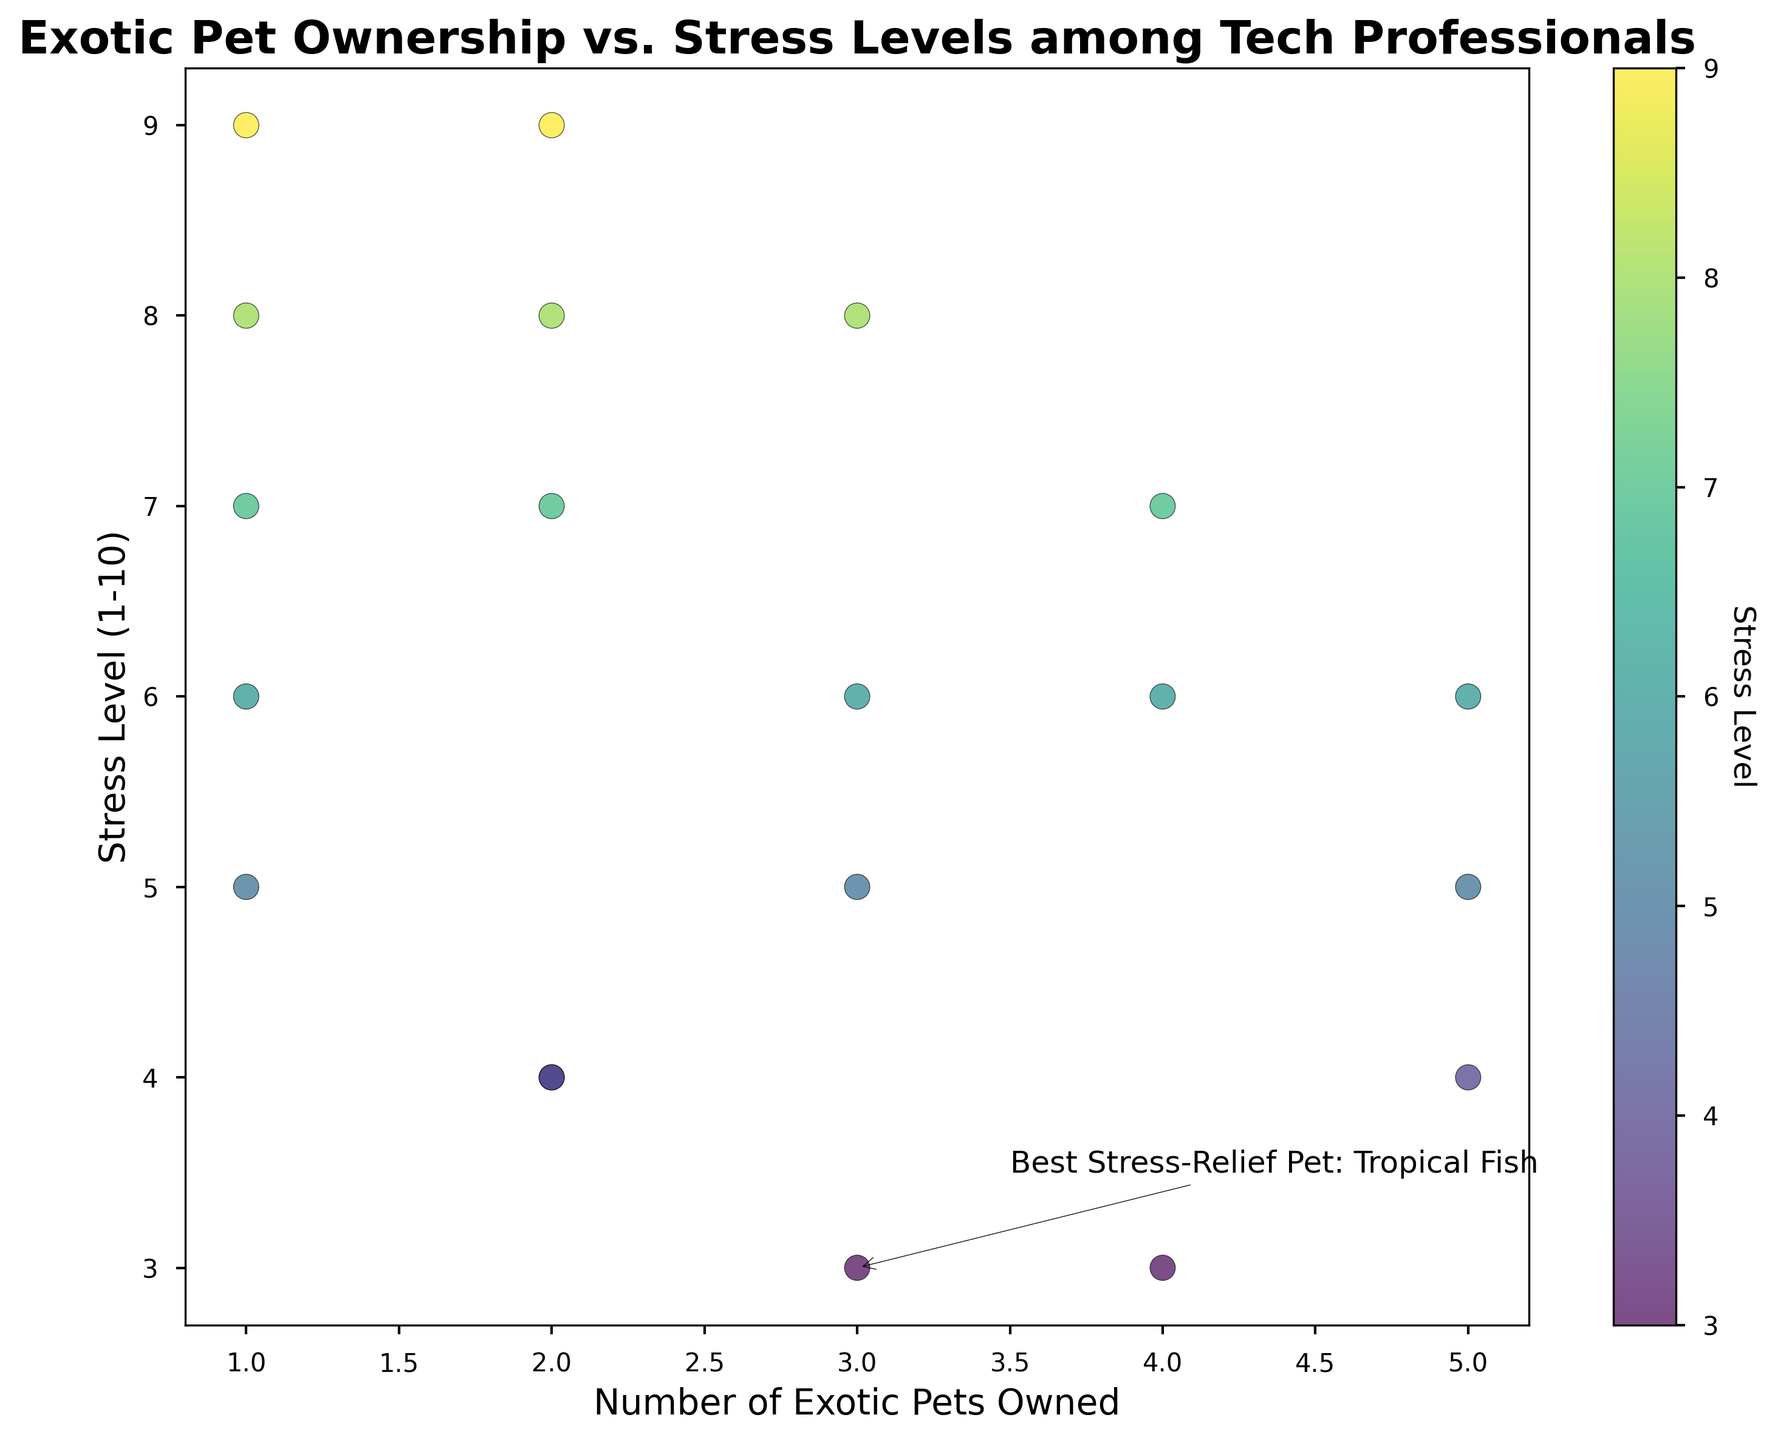What is the relationship between the number of exotic pets and stress level? By examining the scatter plot, one can see that there is no simple linear relationship; however, some general trends can be observed. For example, individuals with fewer pets tend to have a wider range of stress levels, whereas those with more pets (like 5) seem to have moderate stress levels.
Answer: No simple linear relationship Which pet type has the most annotations for lowest stress level? The figure includes an annotation pointing out "Tropical Fish" as the pet type showing the largest positive impact on stress relief (lowest stress level). This is indicated specifically by the text annotation on the plot.
Answer: Tropical Fish How many tech professionals are in the scatter plot? By carefully examining each individual data point on the scatter plot and cross-referencing them with the provided dataset, one can see there are exactly 20 tech professionals represented.
Answer: 20 Is there any tech professional with a stress level of 10? By looking closely at the scatter plot, there are no data points at the stress level of 10, indicating that no tech professional in this dataset has a stress level of 10.
Answer: No What is the stress level of tech professionals owning 4 exotic pets? By locating the data points corresponding to an exotic pets count of 4 on the x-axis and checking their y-axis positions, we can see stress levels of 6, 7, and 3.
Answer: 3, 6, and 7 Which tech professional has the lowest stress level and how many pets do they own? The point annotated on the figure shows the lowest stress level. Checking the annotated point, it indicates the individual with a tropical fish as the most stress-relief pet. The exact coordinates (x, y) should be checked to find the number of pets. In this case, the annotation indicates the person has 3 pets with the lowest stress level of 3.
Answer: A professional with 3 pets How does the average stress level differ between professionals owning 1 pet and those owning 5 pets? Calculate the average stress level for professionals with 1 pet (7, 5, 6, 9, 8) and 5 pets (4, 5, 6). Average stress for 1 pet: (7+5+6+9+8)/5 = 7; Average stress for 5 pets: (4+5+6)/3 = 5
Answer: 7 for 1 pet, 5 for 5 pets Which individual has the highest stress level and what type of stress-relief pet do they have? By looking at the scatter plot for the highest y-value of "Stress Level", one can see that this is a stress level of 9. Cross-referencing the dataset reveals this stress level pertains to tech professionals with Sugar Gliders.
Answer: Sugar Gliders What can you infer about tech professionals owning Sugar Gliders in terms of their stress levels? Locate the data points corresponding to Sugar Gliders. They have stress levels of 9, 7, 8, 9, and 8. This indicates that Sugar Gliders, in this dataset, do not help in significantly reducing stress levels compared to other pets.
Answer: High stress levels Are there any correlations between the color gradient and stress levels observed in the scatter plot? The color gradient (from blue to yellow) indicates varying levels of stress. By looking at the scatter plot, darker colors (towards blue) represent lower stress levels, and lighter colors (towards yellow) represent higher stress levels.
Answer: Yes, from blue (lower stress) to yellow (higher stress) 